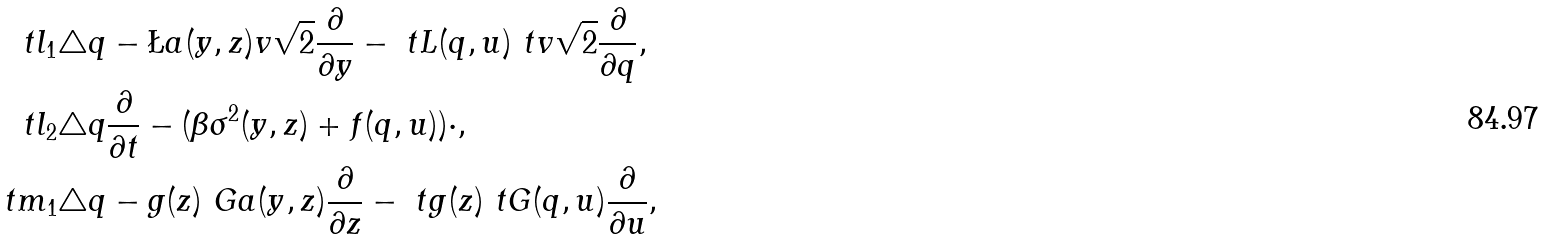<formula> <loc_0><loc_0><loc_500><loc_500>\ t l _ { 1 } & \triangle q - \L a ( y , z ) v \sqrt { 2 } \frac { \partial } { \partial y } - \ t L ( q , u ) \ t v \sqrt { 2 } \frac { \partial } { \partial q } , \\ \ t l _ { 2 } & \triangle q \frac { \partial } { \partial t } - ( \beta \sigma ^ { 2 } ( y , z ) + f ( q , u ) ) \cdot , \\ \ t m _ { 1 } & \triangle q - g ( z ) \ G a ( y , z ) \frac { \partial } { \partial z } - \ t g ( z ) \ t G ( q , u ) \frac { \partial } { \partial u } ,</formula> 